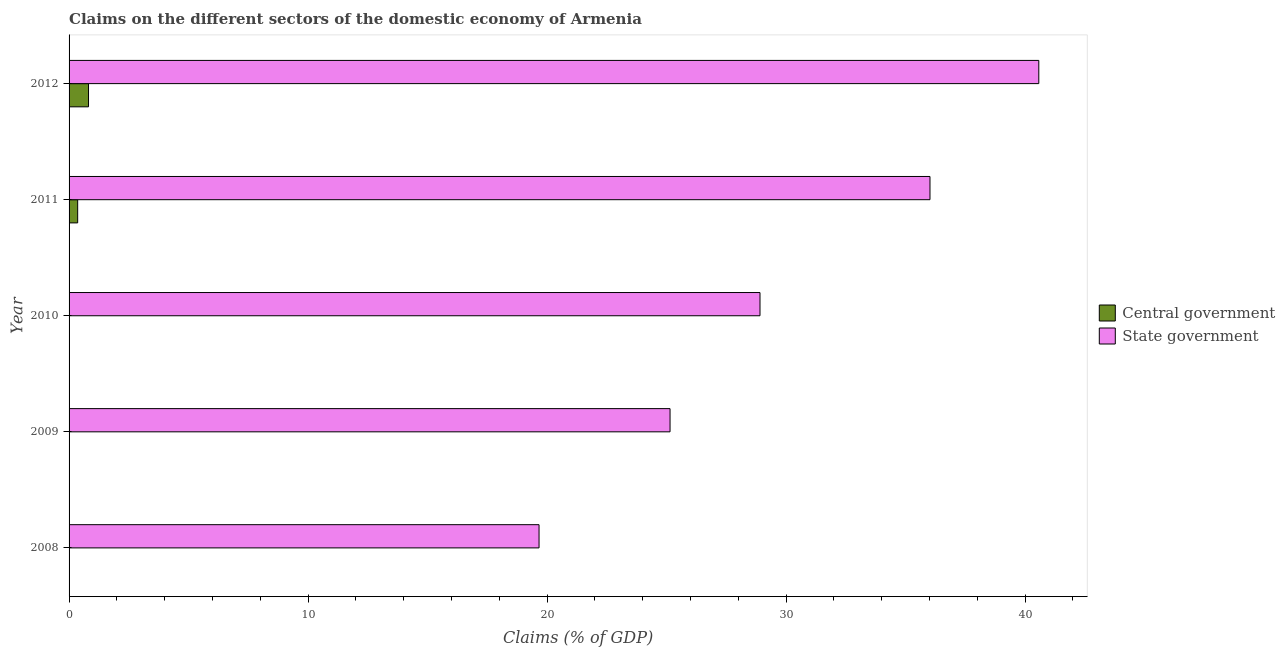How many different coloured bars are there?
Keep it short and to the point. 2. Are the number of bars per tick equal to the number of legend labels?
Offer a terse response. No. How many bars are there on the 3rd tick from the top?
Provide a succinct answer. 1. What is the label of the 1st group of bars from the top?
Your answer should be very brief. 2012. What is the claims on central government in 2012?
Make the answer very short. 0.81. Across all years, what is the maximum claims on central government?
Ensure brevity in your answer.  0.81. What is the total claims on central government in the graph?
Make the answer very short. 1.17. What is the difference between the claims on state government in 2008 and that in 2009?
Provide a succinct answer. -5.48. What is the difference between the claims on state government in 2008 and the claims on central government in 2010?
Provide a short and direct response. 19.66. What is the average claims on state government per year?
Ensure brevity in your answer.  30.06. In the year 2012, what is the difference between the claims on state government and claims on central government?
Give a very brief answer. 39.76. What is the ratio of the claims on state government in 2008 to that in 2010?
Your response must be concise. 0.68. What is the difference between the highest and the second highest claims on state government?
Offer a very short reply. 4.55. What is the difference between the highest and the lowest claims on state government?
Provide a short and direct response. 20.91. In how many years, is the claims on central government greater than the average claims on central government taken over all years?
Give a very brief answer. 2. Is the sum of the claims on central government in 2011 and 2012 greater than the maximum claims on state government across all years?
Make the answer very short. No. How many bars are there?
Make the answer very short. 7. How many years are there in the graph?
Provide a short and direct response. 5. Does the graph contain grids?
Provide a short and direct response. No. How many legend labels are there?
Provide a short and direct response. 2. What is the title of the graph?
Offer a very short reply. Claims on the different sectors of the domestic economy of Armenia. What is the label or title of the X-axis?
Offer a terse response. Claims (% of GDP). What is the label or title of the Y-axis?
Provide a short and direct response. Year. What is the Claims (% of GDP) in State government in 2008?
Offer a terse response. 19.66. What is the Claims (% of GDP) of Central government in 2009?
Your response must be concise. 0. What is the Claims (% of GDP) of State government in 2009?
Offer a very short reply. 25.15. What is the Claims (% of GDP) of State government in 2010?
Give a very brief answer. 28.91. What is the Claims (% of GDP) in Central government in 2011?
Offer a terse response. 0.36. What is the Claims (% of GDP) in State government in 2011?
Keep it short and to the point. 36.02. What is the Claims (% of GDP) of Central government in 2012?
Offer a very short reply. 0.81. What is the Claims (% of GDP) in State government in 2012?
Give a very brief answer. 40.57. Across all years, what is the maximum Claims (% of GDP) of Central government?
Provide a succinct answer. 0.81. Across all years, what is the maximum Claims (% of GDP) of State government?
Provide a succinct answer. 40.57. Across all years, what is the minimum Claims (% of GDP) of State government?
Your response must be concise. 19.66. What is the total Claims (% of GDP) of Central government in the graph?
Your answer should be very brief. 1.17. What is the total Claims (% of GDP) of State government in the graph?
Ensure brevity in your answer.  150.32. What is the difference between the Claims (% of GDP) in State government in 2008 and that in 2009?
Provide a succinct answer. -5.48. What is the difference between the Claims (% of GDP) in State government in 2008 and that in 2010?
Offer a terse response. -9.24. What is the difference between the Claims (% of GDP) of State government in 2008 and that in 2011?
Keep it short and to the point. -16.36. What is the difference between the Claims (% of GDP) in State government in 2008 and that in 2012?
Your answer should be compact. -20.91. What is the difference between the Claims (% of GDP) of State government in 2009 and that in 2010?
Ensure brevity in your answer.  -3.76. What is the difference between the Claims (% of GDP) in State government in 2009 and that in 2011?
Your response must be concise. -10.88. What is the difference between the Claims (% of GDP) in State government in 2009 and that in 2012?
Your answer should be very brief. -15.43. What is the difference between the Claims (% of GDP) of State government in 2010 and that in 2011?
Give a very brief answer. -7.11. What is the difference between the Claims (% of GDP) of State government in 2010 and that in 2012?
Your answer should be very brief. -11.67. What is the difference between the Claims (% of GDP) of Central government in 2011 and that in 2012?
Offer a very short reply. -0.45. What is the difference between the Claims (% of GDP) of State government in 2011 and that in 2012?
Offer a terse response. -4.55. What is the difference between the Claims (% of GDP) in Central government in 2011 and the Claims (% of GDP) in State government in 2012?
Make the answer very short. -40.22. What is the average Claims (% of GDP) in Central government per year?
Provide a succinct answer. 0.23. What is the average Claims (% of GDP) in State government per year?
Your answer should be very brief. 30.06. In the year 2011, what is the difference between the Claims (% of GDP) in Central government and Claims (% of GDP) in State government?
Offer a terse response. -35.66. In the year 2012, what is the difference between the Claims (% of GDP) in Central government and Claims (% of GDP) in State government?
Give a very brief answer. -39.76. What is the ratio of the Claims (% of GDP) of State government in 2008 to that in 2009?
Your answer should be very brief. 0.78. What is the ratio of the Claims (% of GDP) of State government in 2008 to that in 2010?
Ensure brevity in your answer.  0.68. What is the ratio of the Claims (% of GDP) in State government in 2008 to that in 2011?
Your answer should be very brief. 0.55. What is the ratio of the Claims (% of GDP) of State government in 2008 to that in 2012?
Provide a succinct answer. 0.48. What is the ratio of the Claims (% of GDP) in State government in 2009 to that in 2010?
Offer a very short reply. 0.87. What is the ratio of the Claims (% of GDP) of State government in 2009 to that in 2011?
Give a very brief answer. 0.7. What is the ratio of the Claims (% of GDP) in State government in 2009 to that in 2012?
Offer a terse response. 0.62. What is the ratio of the Claims (% of GDP) of State government in 2010 to that in 2011?
Provide a short and direct response. 0.8. What is the ratio of the Claims (% of GDP) of State government in 2010 to that in 2012?
Your response must be concise. 0.71. What is the ratio of the Claims (% of GDP) of Central government in 2011 to that in 2012?
Your answer should be compact. 0.44. What is the ratio of the Claims (% of GDP) in State government in 2011 to that in 2012?
Keep it short and to the point. 0.89. What is the difference between the highest and the second highest Claims (% of GDP) in State government?
Provide a short and direct response. 4.55. What is the difference between the highest and the lowest Claims (% of GDP) of Central government?
Your answer should be very brief. 0.81. What is the difference between the highest and the lowest Claims (% of GDP) of State government?
Offer a very short reply. 20.91. 